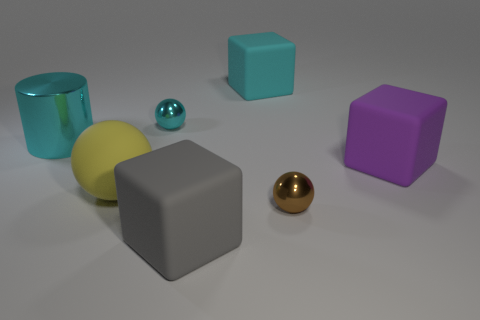What materials do the objects in the image seem to be made of? The objects in the image appear to have various materials. The blue and purple cubes look to have a matte finish suggesting a plastic or painted wood material. The grey cube seems to have a matte metallic or stone finish. The yellow ball has a matte appearance possibly like a rubber material, whereas the two smaller balls appear to have reflective metallic surfaces, suggesting they could be made of metal. 